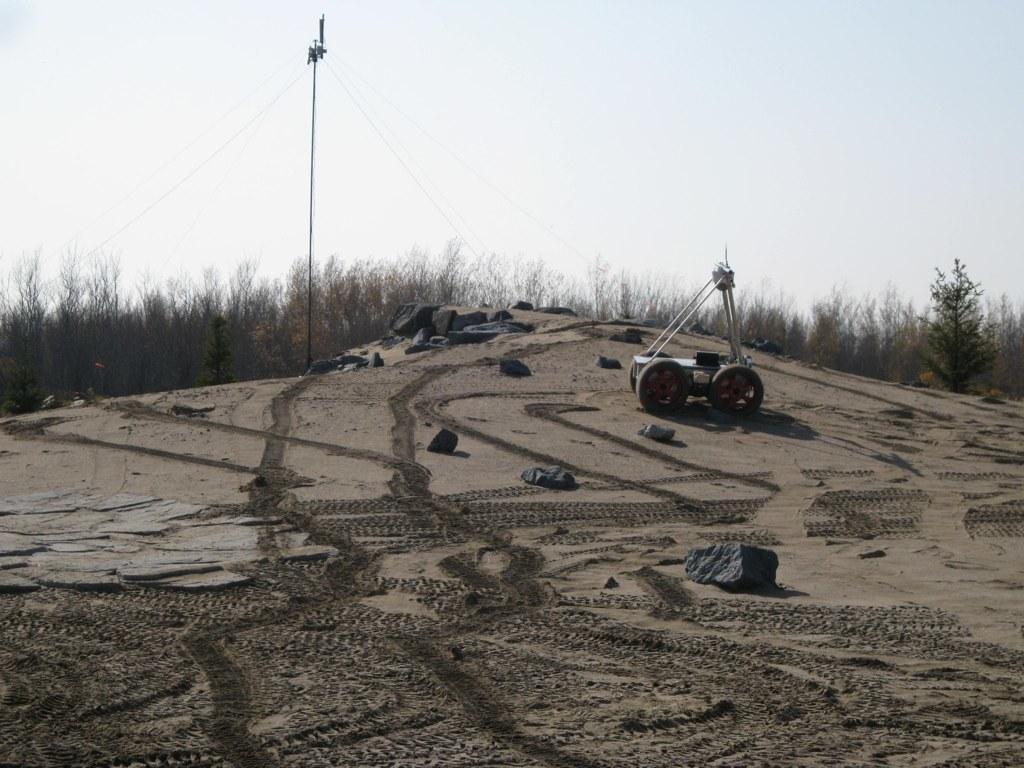Describe this image in one or two sentences. In this image there is an object and a few rocks are on the surface of the sand and in the background there are trees, utility pole and there is the sky. 